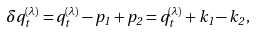<formula> <loc_0><loc_0><loc_500><loc_500>\delta q _ { t } ^ { ( \lambda ) } = q _ { t } ^ { ( \lambda ) } - p _ { 1 } + p _ { 2 } = q _ { t } ^ { ( \lambda ) } + k _ { 1 } - k _ { 2 } \, ,</formula> 